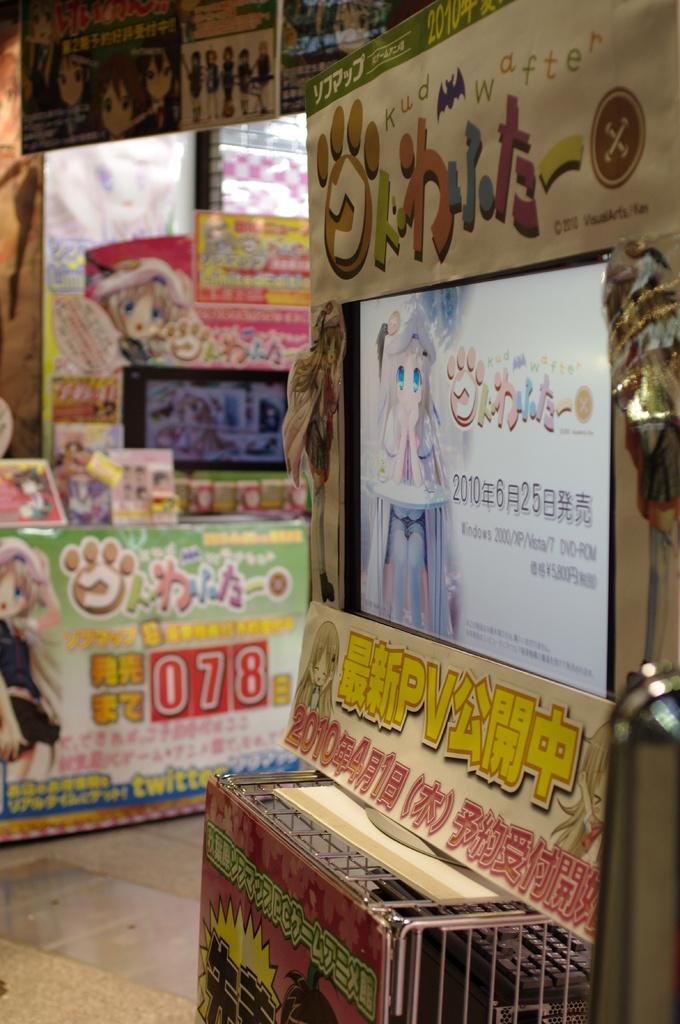What objects are present in the image that have text on them? There are boards, banners, and posters in the image that have text. What other feature do the boards, banners, and posters have in the image? The boards, banners, and posters have pictures in the image. How does the breath of the person in the image affect the sack? There is no person or sack present in the image; it only features boards, banners, and posters. 